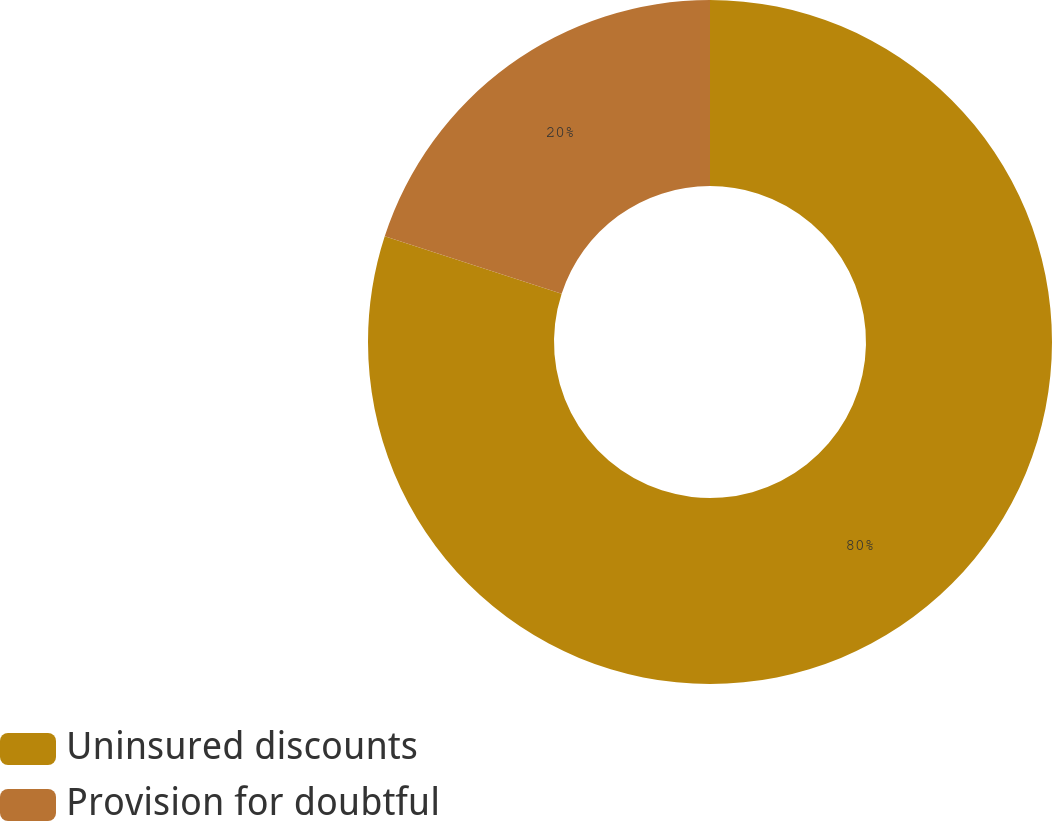Convert chart. <chart><loc_0><loc_0><loc_500><loc_500><pie_chart><fcel>Uninsured discounts<fcel>Provision for doubtful<nl><fcel>80.0%<fcel>20.0%<nl></chart> 